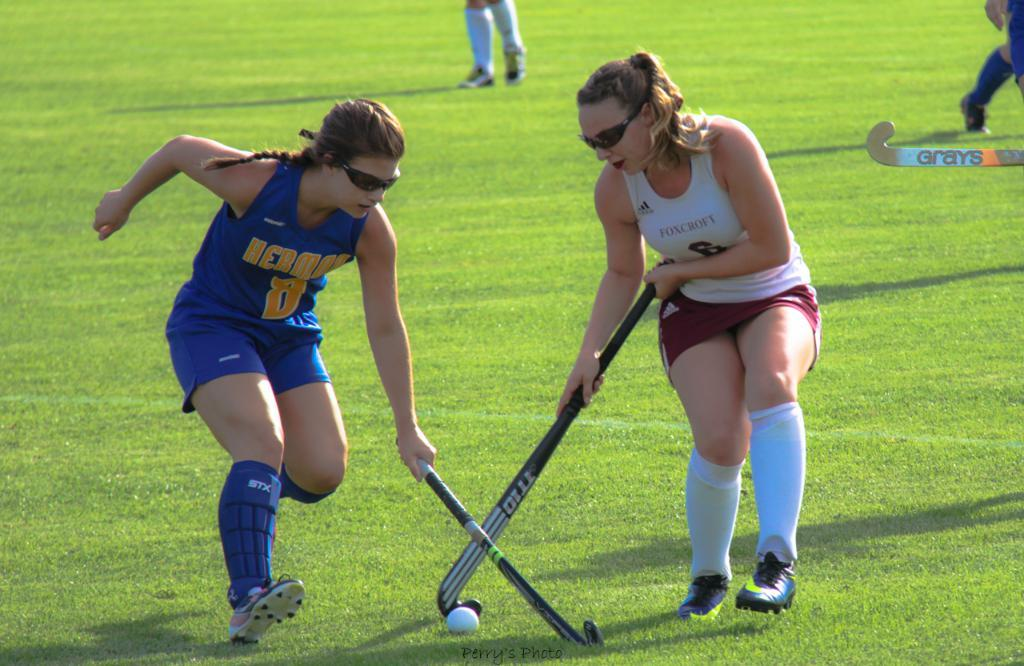Who is present in the image? There are people in the image. What activity are the people engaged in? The people are playing hockey. Where is the hockey game taking place? The hockey game is taking place on the ground. What type of cactus can be seen in the image? There is no cactus present in the image; it features people playing hockey on the ground. Is there any cloth used for decoration in the image? There is no mention of cloth or decoration in the image; it focuses on the people playing hockey. 